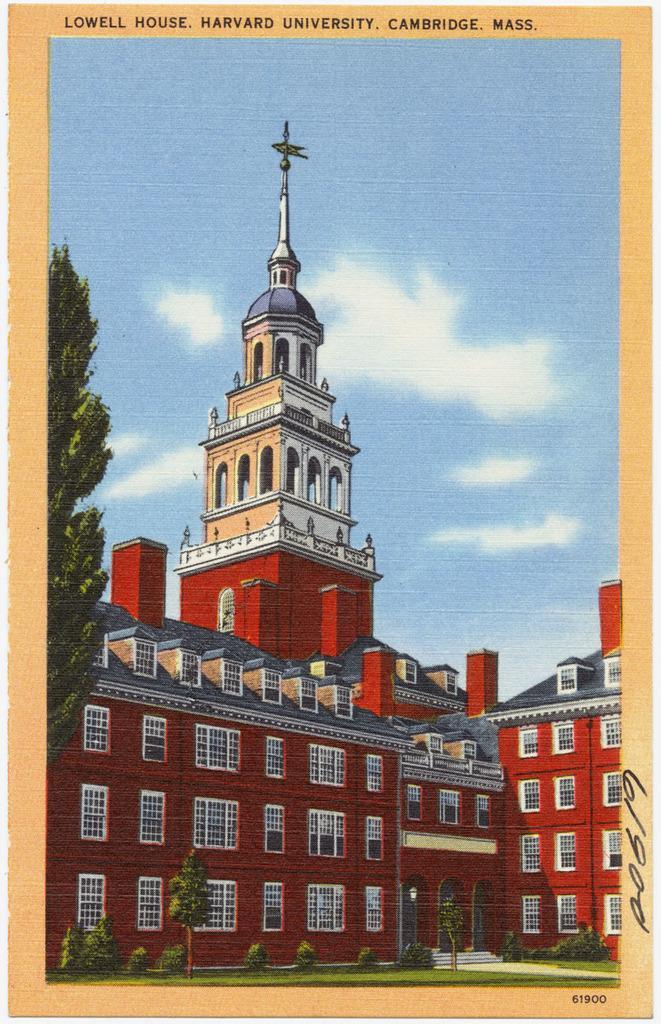Please provide a concise description of this image. In this image I can see a poster in which we can see a big building in front of that there are some plants and tree. 